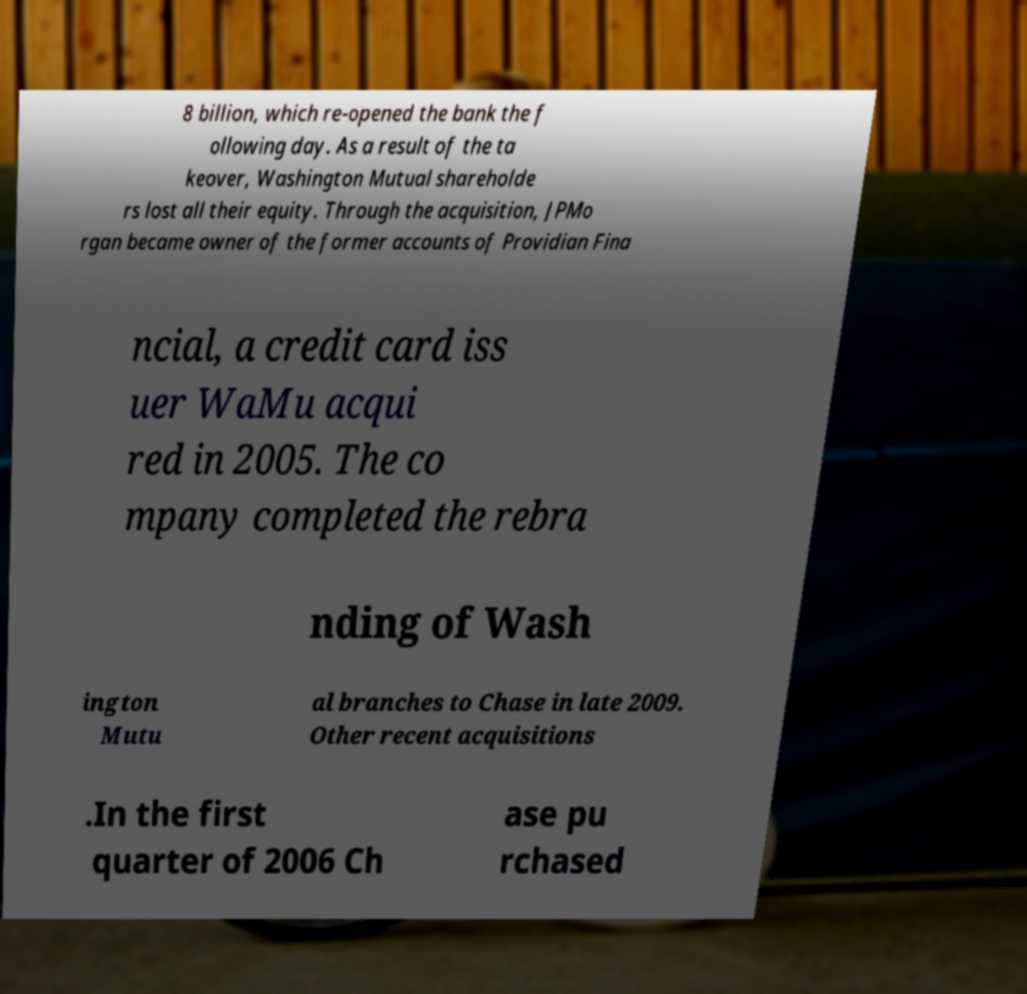What messages or text are displayed in this image? I need them in a readable, typed format. 8 billion, which re-opened the bank the f ollowing day. As a result of the ta keover, Washington Mutual shareholde rs lost all their equity. Through the acquisition, JPMo rgan became owner of the former accounts of Providian Fina ncial, a credit card iss uer WaMu acqui red in 2005. The co mpany completed the rebra nding of Wash ington Mutu al branches to Chase in late 2009. Other recent acquisitions .In the first quarter of 2006 Ch ase pu rchased 